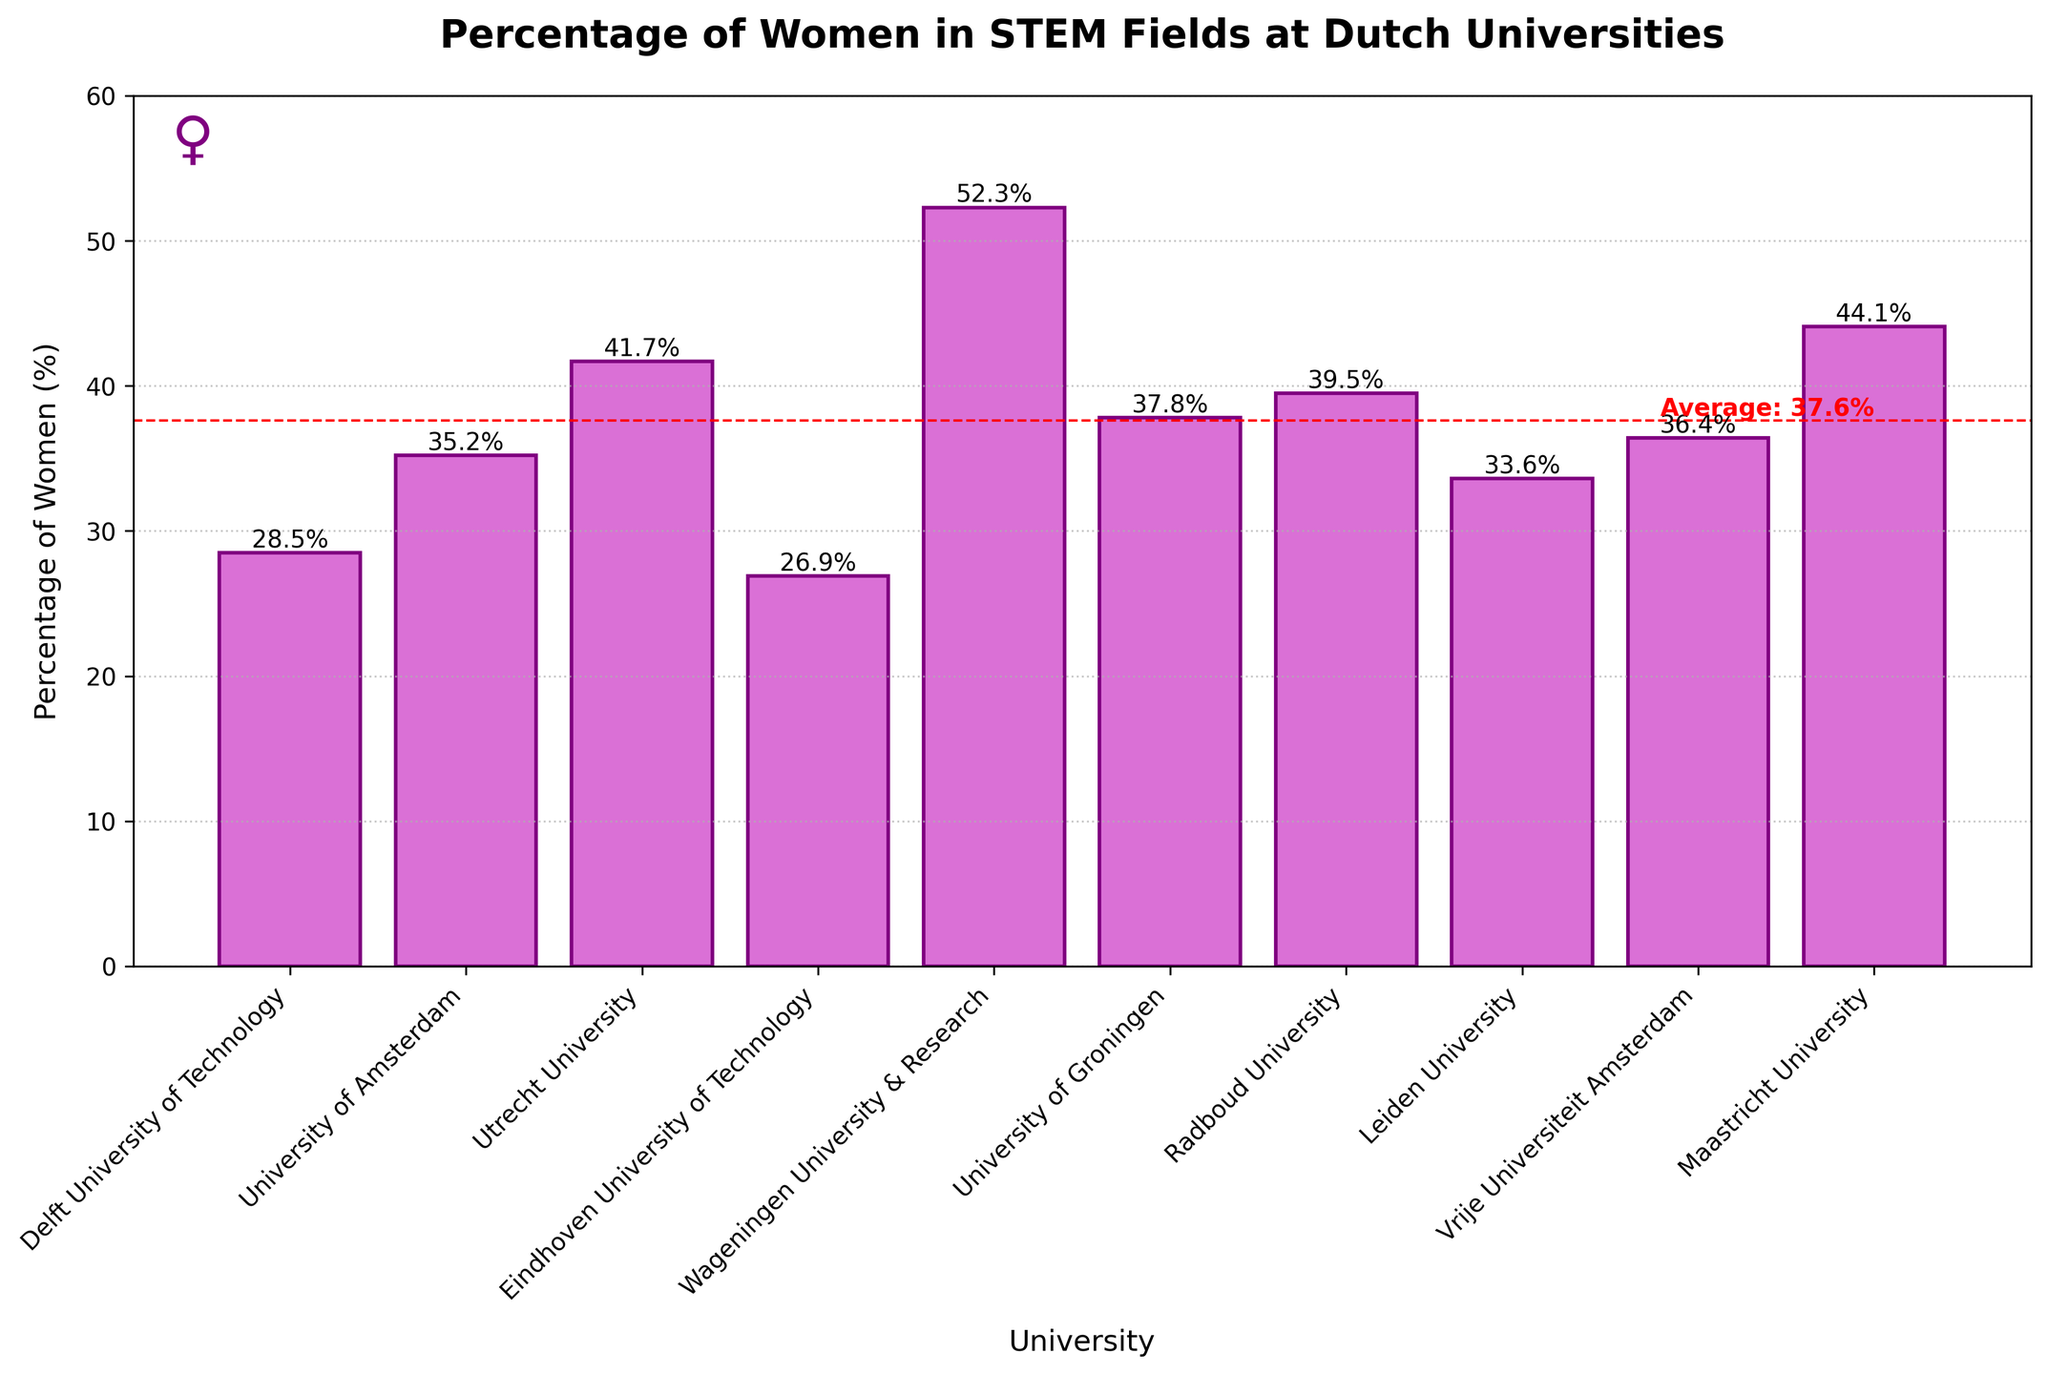What is the percentage of women in STEM at Wageningen University & Research and how does it compare to Radboud University? The percentage of women in STEM at Wageningen University & Research is 52.3% and at Radboud University is 39.5%. To compare, subtract Radboud's percentage from Wageningen's: 52.3% - 39.5% = 12.8%.
Answer: 12.8% higher Which university has the highest percentage of women in STEM fields? Scan the heights of the bars to find the tallest one. Wageningen University & Research, at 52.3%, has the highest percentage.
Answer: Wageningen University & Research What is the lowest percentage of women in STEM among the listed universities? Identify the shortest bar in the chart. Eindhoven University of Technology has the lowest value at 26.9%.
Answer: 26.9% Is the percentage of women in STEM fields at the University of Amsterdam above or below the overall average? The graph shows a red dashed line for the average. The University of Amsterdam's bar is 35.2%, which is below the red dashed line average of around 37.6%.
Answer: Below How many universities have a percentage of women in STEM fields above the average? Count the number of bars above the red dashed line representing the average. Five universities are above the average.
Answer: 5 What is the difference in the percentage of women in STEM between Delft University of Technology and Maastricht University? Maastricht University's percentage is 44.1%, and Delft University of Technology's is 28.5%. Calculate the difference: 44.1% - 28.5% = 15.6%.
Answer: 15.6% Which university has a percentage of women in STEM fields closest to 40%? Identify the bar closest to 40%. Radboud University at 39.5% is the nearest.
Answer: Radboud University Among Vrije Universiteit Amsterdam and Leiden University, which has a higher percentage of women in STEM fields? By how much? Compare the bars: Vrije Universiteit Amsterdam is at 36.4%, and Leiden University is at 33.6%. Calculate the difference: 36.4% - 33.6% = 2.8%.
Answer: Vrije Universiteit Amsterdam by 2.8% What percentage of universities have a percentage of women in STEM fields higher than 35%? There are 10 universities in total. Six of them have percentages above 35% (35 and below count as not higher). Calculate the percentage: (6/10)*100 = 60%.
Answer: 60% Which universities have a percentage of women in STEM fields between 30% and 40%? Identify the bars within the range of 30%-40%. Those universities are: University of Amsterdam (35.2%), Leiden University (33.6%), University of Groningen (37.8%), Vrije Universiteit Amsterdam (36.4%), and Radboud University (39.5%).
Answer: University of Amsterdam, Leiden University, University of Groningen, Vrije Universiteit Amsterdam, Radboud University 